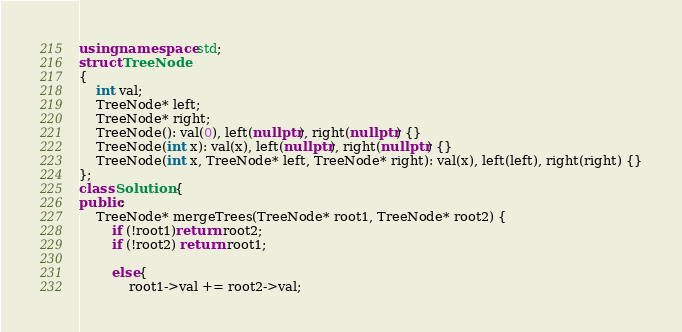Convert code to text. <code><loc_0><loc_0><loc_500><loc_500><_C++_>using namespace std;
struct TreeNode
{
    int val;
    TreeNode* left;
    TreeNode* right;
    TreeNode(): val(0), left(nullptr), right(nullptr) {}
    TreeNode(int x): val(x), left(nullptr), right(nullptr) {}
    TreeNode(int x, TreeNode* left, TreeNode* right): val(x), left(left), right(right) {}
};
class Solution {
public:
    TreeNode* mergeTrees(TreeNode* root1, TreeNode* root2) {
        if (!root1)return root2;
        if (!root2) return root1;

        else{
            root1->val += root2->val;
</code> 